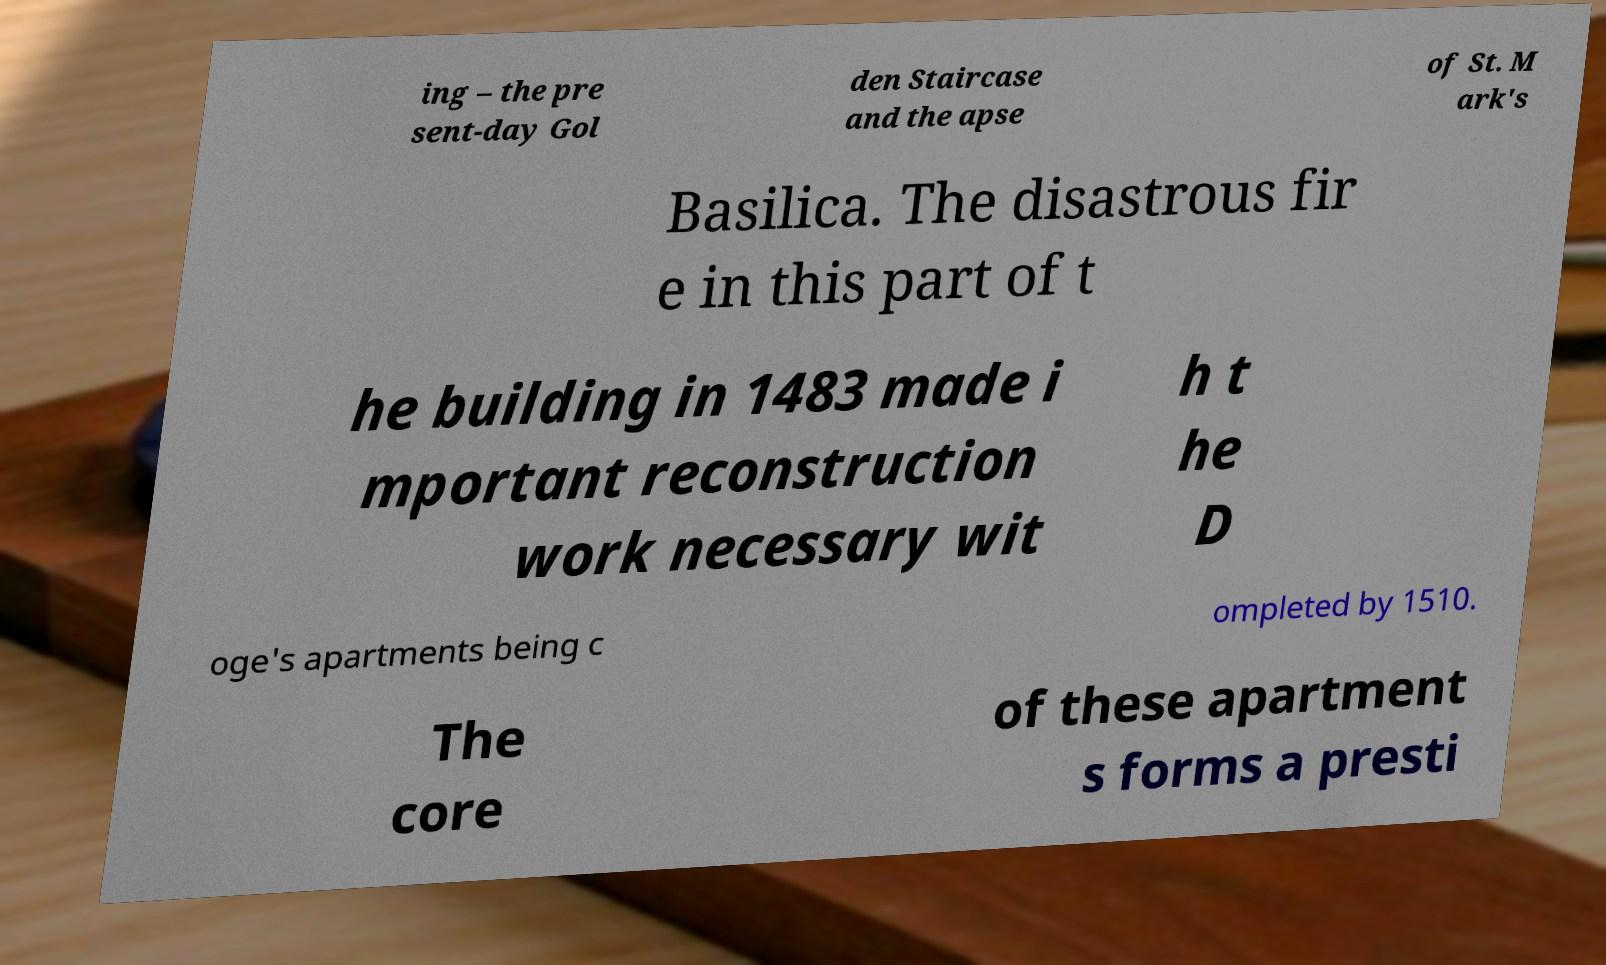Please identify and transcribe the text found in this image. ing – the pre sent-day Gol den Staircase and the apse of St. M ark's Basilica. The disastrous fir e in this part of t he building in 1483 made i mportant reconstruction work necessary wit h t he D oge's apartments being c ompleted by 1510. The core of these apartment s forms a presti 